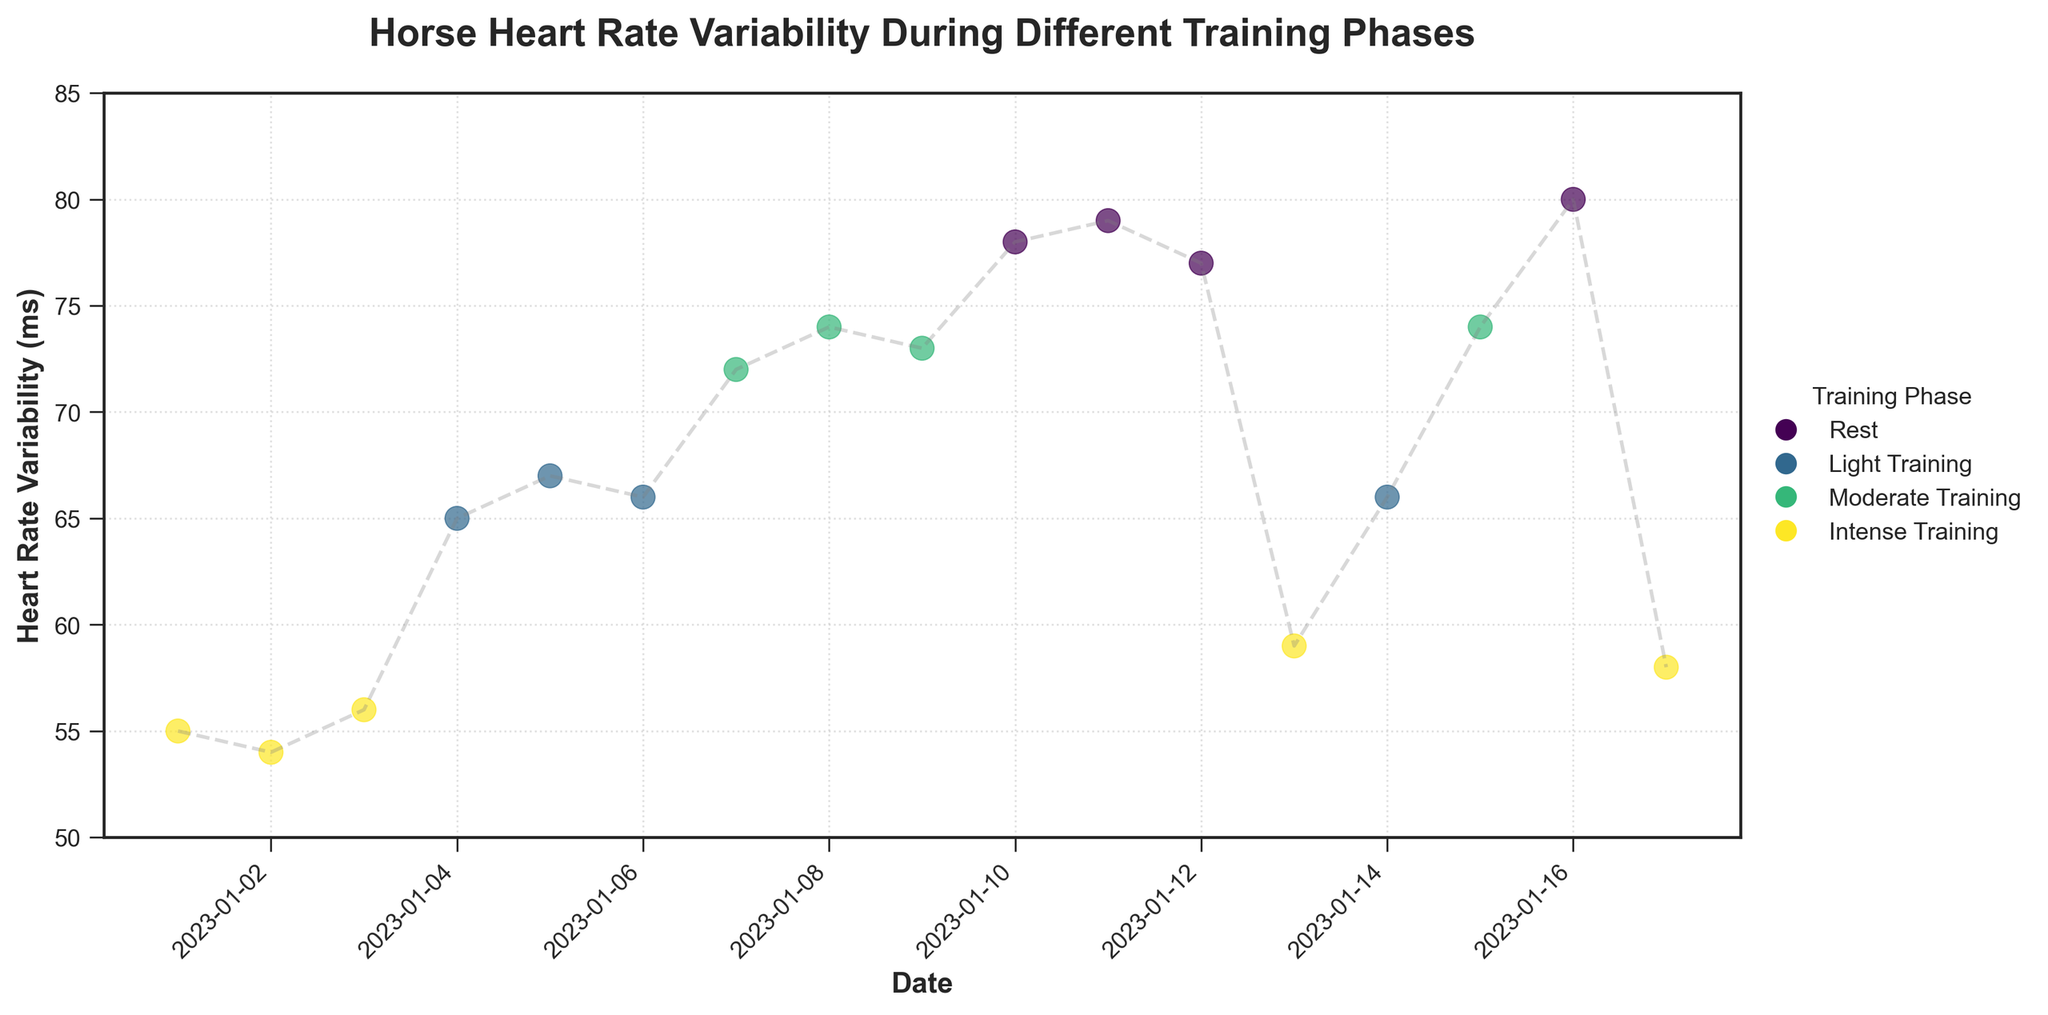How many different training phases are shown in the plot? The legend in the plot shows the different training phases depicted by various colors. By counting the distinct labels in the legend, we can determine the number of training phases.
Answer: 4 What is the heart rate variability range during intense training? By looking at the plotted points for the 'Intense Training' phase and checking the y-axis values, we can identify the minimum and maximum heart rate variability values. These points are 77, 78, 79, and 80 ms.
Answer: 77-80 ms Which training phase shows the highest heart rate variability? Observing the y-axis values and the respective training phases, the highest point on the plot corresponds to the 'Intense Training' phase with a value of 80 ms.
Answer: Intense Training How does the heart rate variability change from rest to light training? Checking values under 'Rest' and 'Light Training' phases, the heart rate variability increases from approximately 55 ms during rest to around 65-67 ms during light training.
Answer: It increases What is the average heart rate variability during light training? Summing the heart rate variabilities during 'Light Training' (65, 67, 66, 66) and dividing by the count of these values, which is 4, the average is calculated as (65 + 67 + 66 + 66) / 4.
Answer: 66 ms Which phase has the lowest heart rate variability value? By checking the y-axis and identifying the minimum plotted point, we see it is during the 'Rest' training phase with a value of 54 ms.
Answer: Rest How does the heart rate variability change over time during the 'Moderate Training' phase? Observing the scattered points and line connections in the 'Moderate Training' phase across dates, we see a generally increasing pattern with slight variations: from 72 to 74 ms, then a slight drop to 73.
Answer: It generally increases What is the difference in heart rate variability between the first and last date in the plot? Comparing the heart rate variability values on January 1st (55 ms) and January 17th (58 ms), we subtract the former from the latter to get the difference: 58 - 55.
Answer: 3 ms Which training phase exhibits the most consistent heart rate variability? By observing the plot, we can notice the variance in values within each phase. 'Rest' and 'Light Training' are relatively consistent compared to 'Moderate' and 'Intense Training.'
Answer: Light Training 